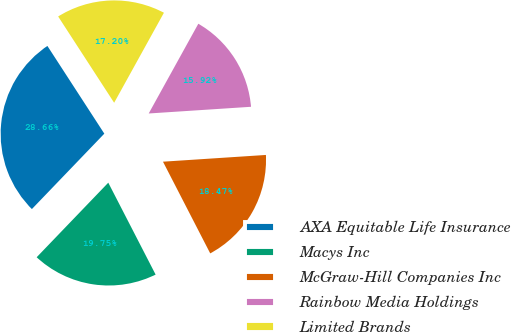Convert chart to OTSL. <chart><loc_0><loc_0><loc_500><loc_500><pie_chart><fcel>AXA Equitable Life Insurance<fcel>Macys Inc<fcel>McGraw-Hill Companies Inc<fcel>Rainbow Media Holdings<fcel>Limited Brands<nl><fcel>28.66%<fcel>19.75%<fcel>18.47%<fcel>15.92%<fcel>17.2%<nl></chart> 